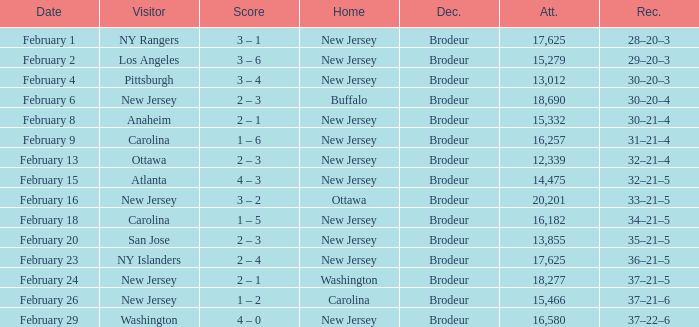What was the record when the visiting team was Ottawa? 32–21–4. 